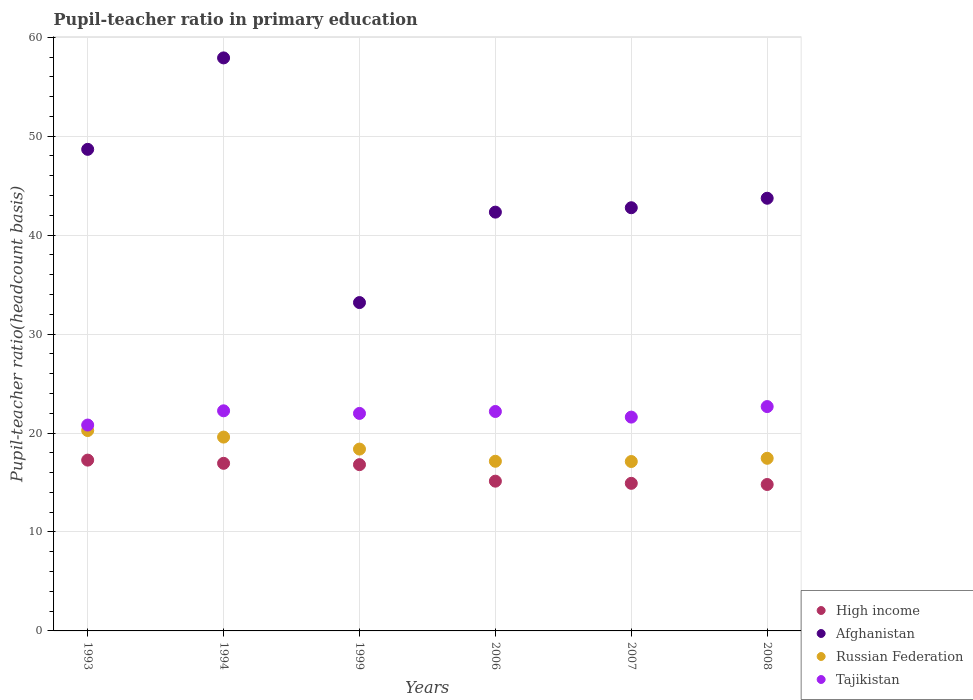How many different coloured dotlines are there?
Offer a terse response. 4. What is the pupil-teacher ratio in primary education in Russian Federation in 1993?
Ensure brevity in your answer.  20.25. Across all years, what is the maximum pupil-teacher ratio in primary education in Afghanistan?
Ensure brevity in your answer.  57.91. Across all years, what is the minimum pupil-teacher ratio in primary education in Tajikistan?
Offer a very short reply. 20.81. In which year was the pupil-teacher ratio in primary education in Tajikistan maximum?
Offer a terse response. 2008. In which year was the pupil-teacher ratio in primary education in High income minimum?
Keep it short and to the point. 2008. What is the total pupil-teacher ratio in primary education in High income in the graph?
Provide a succinct answer. 95.86. What is the difference between the pupil-teacher ratio in primary education in Tajikistan in 1994 and that in 2007?
Provide a short and direct response. 0.64. What is the difference between the pupil-teacher ratio in primary education in High income in 2006 and the pupil-teacher ratio in primary education in Tajikistan in 1993?
Ensure brevity in your answer.  -5.67. What is the average pupil-teacher ratio in primary education in Afghanistan per year?
Keep it short and to the point. 44.77. In the year 1994, what is the difference between the pupil-teacher ratio in primary education in Afghanistan and pupil-teacher ratio in primary education in Russian Federation?
Your answer should be very brief. 38.32. What is the ratio of the pupil-teacher ratio in primary education in High income in 1993 to that in 2007?
Provide a succinct answer. 1.16. Is the difference between the pupil-teacher ratio in primary education in Afghanistan in 2007 and 2008 greater than the difference between the pupil-teacher ratio in primary education in Russian Federation in 2007 and 2008?
Provide a short and direct response. No. What is the difference between the highest and the second highest pupil-teacher ratio in primary education in Russian Federation?
Provide a succinct answer. 0.66. What is the difference between the highest and the lowest pupil-teacher ratio in primary education in Afghanistan?
Make the answer very short. 24.73. In how many years, is the pupil-teacher ratio in primary education in Afghanistan greater than the average pupil-teacher ratio in primary education in Afghanistan taken over all years?
Give a very brief answer. 2. Is it the case that in every year, the sum of the pupil-teacher ratio in primary education in Russian Federation and pupil-teacher ratio in primary education in High income  is greater than the sum of pupil-teacher ratio in primary education in Afghanistan and pupil-teacher ratio in primary education in Tajikistan?
Your response must be concise. No. Is it the case that in every year, the sum of the pupil-teacher ratio in primary education in Afghanistan and pupil-teacher ratio in primary education in High income  is greater than the pupil-teacher ratio in primary education in Russian Federation?
Keep it short and to the point. Yes. Is the pupil-teacher ratio in primary education in Afghanistan strictly less than the pupil-teacher ratio in primary education in Russian Federation over the years?
Ensure brevity in your answer.  No. How many years are there in the graph?
Offer a very short reply. 6. Are the values on the major ticks of Y-axis written in scientific E-notation?
Keep it short and to the point. No. How many legend labels are there?
Offer a terse response. 4. How are the legend labels stacked?
Provide a short and direct response. Vertical. What is the title of the graph?
Your answer should be very brief. Pupil-teacher ratio in primary education. Does "Fragile and conflict affected situations" appear as one of the legend labels in the graph?
Provide a short and direct response. No. What is the label or title of the Y-axis?
Your answer should be compact. Pupil-teacher ratio(headcount basis). What is the Pupil-teacher ratio(headcount basis) in High income in 1993?
Provide a short and direct response. 17.26. What is the Pupil-teacher ratio(headcount basis) of Afghanistan in 1993?
Your answer should be very brief. 48.67. What is the Pupil-teacher ratio(headcount basis) in Russian Federation in 1993?
Provide a short and direct response. 20.25. What is the Pupil-teacher ratio(headcount basis) of Tajikistan in 1993?
Your answer should be compact. 20.81. What is the Pupil-teacher ratio(headcount basis) of High income in 1994?
Ensure brevity in your answer.  16.94. What is the Pupil-teacher ratio(headcount basis) in Afghanistan in 1994?
Provide a short and direct response. 57.91. What is the Pupil-teacher ratio(headcount basis) in Russian Federation in 1994?
Keep it short and to the point. 19.59. What is the Pupil-teacher ratio(headcount basis) of Tajikistan in 1994?
Offer a very short reply. 22.25. What is the Pupil-teacher ratio(headcount basis) in High income in 1999?
Ensure brevity in your answer.  16.8. What is the Pupil-teacher ratio(headcount basis) of Afghanistan in 1999?
Offer a terse response. 33.19. What is the Pupil-teacher ratio(headcount basis) of Russian Federation in 1999?
Offer a terse response. 18.38. What is the Pupil-teacher ratio(headcount basis) of Tajikistan in 1999?
Your response must be concise. 21.98. What is the Pupil-teacher ratio(headcount basis) of High income in 2006?
Give a very brief answer. 15.14. What is the Pupil-teacher ratio(headcount basis) in Afghanistan in 2006?
Ensure brevity in your answer.  42.33. What is the Pupil-teacher ratio(headcount basis) in Russian Federation in 2006?
Your response must be concise. 17.15. What is the Pupil-teacher ratio(headcount basis) of Tajikistan in 2006?
Your answer should be compact. 22.18. What is the Pupil-teacher ratio(headcount basis) of High income in 2007?
Offer a terse response. 14.92. What is the Pupil-teacher ratio(headcount basis) in Afghanistan in 2007?
Ensure brevity in your answer.  42.77. What is the Pupil-teacher ratio(headcount basis) in Russian Federation in 2007?
Provide a short and direct response. 17.12. What is the Pupil-teacher ratio(headcount basis) in Tajikistan in 2007?
Provide a short and direct response. 21.61. What is the Pupil-teacher ratio(headcount basis) of High income in 2008?
Give a very brief answer. 14.8. What is the Pupil-teacher ratio(headcount basis) in Afghanistan in 2008?
Your answer should be compact. 43.73. What is the Pupil-teacher ratio(headcount basis) of Russian Federation in 2008?
Offer a terse response. 17.45. What is the Pupil-teacher ratio(headcount basis) in Tajikistan in 2008?
Provide a short and direct response. 22.67. Across all years, what is the maximum Pupil-teacher ratio(headcount basis) of High income?
Keep it short and to the point. 17.26. Across all years, what is the maximum Pupil-teacher ratio(headcount basis) in Afghanistan?
Your response must be concise. 57.91. Across all years, what is the maximum Pupil-teacher ratio(headcount basis) of Russian Federation?
Make the answer very short. 20.25. Across all years, what is the maximum Pupil-teacher ratio(headcount basis) of Tajikistan?
Give a very brief answer. 22.67. Across all years, what is the minimum Pupil-teacher ratio(headcount basis) in High income?
Your answer should be compact. 14.8. Across all years, what is the minimum Pupil-teacher ratio(headcount basis) in Afghanistan?
Make the answer very short. 33.19. Across all years, what is the minimum Pupil-teacher ratio(headcount basis) in Russian Federation?
Offer a terse response. 17.12. Across all years, what is the minimum Pupil-teacher ratio(headcount basis) of Tajikistan?
Provide a succinct answer. 20.81. What is the total Pupil-teacher ratio(headcount basis) in High income in the graph?
Your response must be concise. 95.86. What is the total Pupil-teacher ratio(headcount basis) of Afghanistan in the graph?
Provide a short and direct response. 268.6. What is the total Pupil-teacher ratio(headcount basis) in Russian Federation in the graph?
Make the answer very short. 109.93. What is the total Pupil-teacher ratio(headcount basis) of Tajikistan in the graph?
Your response must be concise. 131.5. What is the difference between the Pupil-teacher ratio(headcount basis) in High income in 1993 and that in 1994?
Keep it short and to the point. 0.32. What is the difference between the Pupil-teacher ratio(headcount basis) of Afghanistan in 1993 and that in 1994?
Your answer should be compact. -9.24. What is the difference between the Pupil-teacher ratio(headcount basis) in Russian Federation in 1993 and that in 1994?
Keep it short and to the point. 0.66. What is the difference between the Pupil-teacher ratio(headcount basis) of Tajikistan in 1993 and that in 1994?
Offer a terse response. -1.44. What is the difference between the Pupil-teacher ratio(headcount basis) in High income in 1993 and that in 1999?
Keep it short and to the point. 0.46. What is the difference between the Pupil-teacher ratio(headcount basis) of Afghanistan in 1993 and that in 1999?
Keep it short and to the point. 15.49. What is the difference between the Pupil-teacher ratio(headcount basis) in Russian Federation in 1993 and that in 1999?
Keep it short and to the point. 1.87. What is the difference between the Pupil-teacher ratio(headcount basis) of Tajikistan in 1993 and that in 1999?
Make the answer very short. -1.18. What is the difference between the Pupil-teacher ratio(headcount basis) of High income in 1993 and that in 2006?
Your answer should be compact. 2.13. What is the difference between the Pupil-teacher ratio(headcount basis) of Afghanistan in 1993 and that in 2006?
Offer a very short reply. 6.35. What is the difference between the Pupil-teacher ratio(headcount basis) of Russian Federation in 1993 and that in 2006?
Ensure brevity in your answer.  3.1. What is the difference between the Pupil-teacher ratio(headcount basis) of Tajikistan in 1993 and that in 2006?
Give a very brief answer. -1.37. What is the difference between the Pupil-teacher ratio(headcount basis) in High income in 1993 and that in 2007?
Make the answer very short. 2.35. What is the difference between the Pupil-teacher ratio(headcount basis) of Afghanistan in 1993 and that in 2007?
Offer a terse response. 5.9. What is the difference between the Pupil-teacher ratio(headcount basis) of Russian Federation in 1993 and that in 2007?
Make the answer very short. 3.13. What is the difference between the Pupil-teacher ratio(headcount basis) of Tajikistan in 1993 and that in 2007?
Make the answer very short. -0.8. What is the difference between the Pupil-teacher ratio(headcount basis) of High income in 1993 and that in 2008?
Offer a terse response. 2.46. What is the difference between the Pupil-teacher ratio(headcount basis) of Afghanistan in 1993 and that in 2008?
Keep it short and to the point. 4.94. What is the difference between the Pupil-teacher ratio(headcount basis) of Russian Federation in 1993 and that in 2008?
Your answer should be compact. 2.81. What is the difference between the Pupil-teacher ratio(headcount basis) of Tajikistan in 1993 and that in 2008?
Provide a succinct answer. -1.87. What is the difference between the Pupil-teacher ratio(headcount basis) in High income in 1994 and that in 1999?
Give a very brief answer. 0.14. What is the difference between the Pupil-teacher ratio(headcount basis) in Afghanistan in 1994 and that in 1999?
Your response must be concise. 24.73. What is the difference between the Pupil-teacher ratio(headcount basis) of Russian Federation in 1994 and that in 1999?
Your answer should be very brief. 1.21. What is the difference between the Pupil-teacher ratio(headcount basis) of Tajikistan in 1994 and that in 1999?
Provide a short and direct response. 0.26. What is the difference between the Pupil-teacher ratio(headcount basis) in High income in 1994 and that in 2006?
Provide a succinct answer. 1.8. What is the difference between the Pupil-teacher ratio(headcount basis) in Afghanistan in 1994 and that in 2006?
Offer a terse response. 15.59. What is the difference between the Pupil-teacher ratio(headcount basis) of Russian Federation in 1994 and that in 2006?
Offer a very short reply. 2.44. What is the difference between the Pupil-teacher ratio(headcount basis) of Tajikistan in 1994 and that in 2006?
Keep it short and to the point. 0.07. What is the difference between the Pupil-teacher ratio(headcount basis) in High income in 1994 and that in 2007?
Your answer should be compact. 2.02. What is the difference between the Pupil-teacher ratio(headcount basis) in Afghanistan in 1994 and that in 2007?
Offer a very short reply. 15.14. What is the difference between the Pupil-teacher ratio(headcount basis) in Russian Federation in 1994 and that in 2007?
Offer a terse response. 2.47. What is the difference between the Pupil-teacher ratio(headcount basis) in Tajikistan in 1994 and that in 2007?
Provide a short and direct response. 0.64. What is the difference between the Pupil-teacher ratio(headcount basis) in High income in 1994 and that in 2008?
Your answer should be very brief. 2.14. What is the difference between the Pupil-teacher ratio(headcount basis) in Afghanistan in 1994 and that in 2008?
Keep it short and to the point. 14.18. What is the difference between the Pupil-teacher ratio(headcount basis) in Russian Federation in 1994 and that in 2008?
Offer a very short reply. 2.14. What is the difference between the Pupil-teacher ratio(headcount basis) of Tajikistan in 1994 and that in 2008?
Your answer should be very brief. -0.43. What is the difference between the Pupil-teacher ratio(headcount basis) in High income in 1999 and that in 2006?
Your response must be concise. 1.67. What is the difference between the Pupil-teacher ratio(headcount basis) in Afghanistan in 1999 and that in 2006?
Your answer should be compact. -9.14. What is the difference between the Pupil-teacher ratio(headcount basis) in Russian Federation in 1999 and that in 2006?
Make the answer very short. 1.23. What is the difference between the Pupil-teacher ratio(headcount basis) of Tajikistan in 1999 and that in 2006?
Provide a short and direct response. -0.2. What is the difference between the Pupil-teacher ratio(headcount basis) in High income in 1999 and that in 2007?
Make the answer very short. 1.89. What is the difference between the Pupil-teacher ratio(headcount basis) in Afghanistan in 1999 and that in 2007?
Provide a succinct answer. -9.58. What is the difference between the Pupil-teacher ratio(headcount basis) of Russian Federation in 1999 and that in 2007?
Ensure brevity in your answer.  1.26. What is the difference between the Pupil-teacher ratio(headcount basis) in Tajikistan in 1999 and that in 2007?
Make the answer very short. 0.37. What is the difference between the Pupil-teacher ratio(headcount basis) of High income in 1999 and that in 2008?
Offer a terse response. 2.01. What is the difference between the Pupil-teacher ratio(headcount basis) in Afghanistan in 1999 and that in 2008?
Provide a succinct answer. -10.54. What is the difference between the Pupil-teacher ratio(headcount basis) of Russian Federation in 1999 and that in 2008?
Provide a succinct answer. 0.93. What is the difference between the Pupil-teacher ratio(headcount basis) of Tajikistan in 1999 and that in 2008?
Provide a succinct answer. -0.69. What is the difference between the Pupil-teacher ratio(headcount basis) of High income in 2006 and that in 2007?
Keep it short and to the point. 0.22. What is the difference between the Pupil-teacher ratio(headcount basis) in Afghanistan in 2006 and that in 2007?
Offer a terse response. -0.44. What is the difference between the Pupil-teacher ratio(headcount basis) of Russian Federation in 2006 and that in 2007?
Offer a terse response. 0.03. What is the difference between the Pupil-teacher ratio(headcount basis) in Tajikistan in 2006 and that in 2007?
Offer a very short reply. 0.57. What is the difference between the Pupil-teacher ratio(headcount basis) in High income in 2006 and that in 2008?
Give a very brief answer. 0.34. What is the difference between the Pupil-teacher ratio(headcount basis) of Afghanistan in 2006 and that in 2008?
Provide a succinct answer. -1.4. What is the difference between the Pupil-teacher ratio(headcount basis) in Tajikistan in 2006 and that in 2008?
Ensure brevity in your answer.  -0.5. What is the difference between the Pupil-teacher ratio(headcount basis) of High income in 2007 and that in 2008?
Keep it short and to the point. 0.12. What is the difference between the Pupil-teacher ratio(headcount basis) of Afghanistan in 2007 and that in 2008?
Provide a succinct answer. -0.96. What is the difference between the Pupil-teacher ratio(headcount basis) of Russian Federation in 2007 and that in 2008?
Keep it short and to the point. -0.33. What is the difference between the Pupil-teacher ratio(headcount basis) in Tajikistan in 2007 and that in 2008?
Your answer should be very brief. -1.06. What is the difference between the Pupil-teacher ratio(headcount basis) in High income in 1993 and the Pupil-teacher ratio(headcount basis) in Afghanistan in 1994?
Your answer should be very brief. -40.65. What is the difference between the Pupil-teacher ratio(headcount basis) of High income in 1993 and the Pupil-teacher ratio(headcount basis) of Russian Federation in 1994?
Your response must be concise. -2.33. What is the difference between the Pupil-teacher ratio(headcount basis) in High income in 1993 and the Pupil-teacher ratio(headcount basis) in Tajikistan in 1994?
Make the answer very short. -4.98. What is the difference between the Pupil-teacher ratio(headcount basis) in Afghanistan in 1993 and the Pupil-teacher ratio(headcount basis) in Russian Federation in 1994?
Offer a terse response. 29.08. What is the difference between the Pupil-teacher ratio(headcount basis) of Afghanistan in 1993 and the Pupil-teacher ratio(headcount basis) of Tajikistan in 1994?
Your answer should be very brief. 26.43. What is the difference between the Pupil-teacher ratio(headcount basis) of Russian Federation in 1993 and the Pupil-teacher ratio(headcount basis) of Tajikistan in 1994?
Make the answer very short. -1.99. What is the difference between the Pupil-teacher ratio(headcount basis) in High income in 1993 and the Pupil-teacher ratio(headcount basis) in Afghanistan in 1999?
Ensure brevity in your answer.  -15.92. What is the difference between the Pupil-teacher ratio(headcount basis) in High income in 1993 and the Pupil-teacher ratio(headcount basis) in Russian Federation in 1999?
Your response must be concise. -1.11. What is the difference between the Pupil-teacher ratio(headcount basis) of High income in 1993 and the Pupil-teacher ratio(headcount basis) of Tajikistan in 1999?
Keep it short and to the point. -4.72. What is the difference between the Pupil-teacher ratio(headcount basis) in Afghanistan in 1993 and the Pupil-teacher ratio(headcount basis) in Russian Federation in 1999?
Offer a terse response. 30.29. What is the difference between the Pupil-teacher ratio(headcount basis) in Afghanistan in 1993 and the Pupil-teacher ratio(headcount basis) in Tajikistan in 1999?
Give a very brief answer. 26.69. What is the difference between the Pupil-teacher ratio(headcount basis) in Russian Federation in 1993 and the Pupil-teacher ratio(headcount basis) in Tajikistan in 1999?
Give a very brief answer. -1.73. What is the difference between the Pupil-teacher ratio(headcount basis) in High income in 1993 and the Pupil-teacher ratio(headcount basis) in Afghanistan in 2006?
Your answer should be compact. -25.06. What is the difference between the Pupil-teacher ratio(headcount basis) of High income in 1993 and the Pupil-teacher ratio(headcount basis) of Russian Federation in 2006?
Offer a terse response. 0.12. What is the difference between the Pupil-teacher ratio(headcount basis) of High income in 1993 and the Pupil-teacher ratio(headcount basis) of Tajikistan in 2006?
Make the answer very short. -4.92. What is the difference between the Pupil-teacher ratio(headcount basis) in Afghanistan in 1993 and the Pupil-teacher ratio(headcount basis) in Russian Federation in 2006?
Offer a terse response. 31.52. What is the difference between the Pupil-teacher ratio(headcount basis) of Afghanistan in 1993 and the Pupil-teacher ratio(headcount basis) of Tajikistan in 2006?
Your answer should be very brief. 26.49. What is the difference between the Pupil-teacher ratio(headcount basis) of Russian Federation in 1993 and the Pupil-teacher ratio(headcount basis) of Tajikistan in 2006?
Your response must be concise. -1.93. What is the difference between the Pupil-teacher ratio(headcount basis) of High income in 1993 and the Pupil-teacher ratio(headcount basis) of Afghanistan in 2007?
Offer a very short reply. -25.51. What is the difference between the Pupil-teacher ratio(headcount basis) of High income in 1993 and the Pupil-teacher ratio(headcount basis) of Russian Federation in 2007?
Ensure brevity in your answer.  0.14. What is the difference between the Pupil-teacher ratio(headcount basis) of High income in 1993 and the Pupil-teacher ratio(headcount basis) of Tajikistan in 2007?
Make the answer very short. -4.35. What is the difference between the Pupil-teacher ratio(headcount basis) of Afghanistan in 1993 and the Pupil-teacher ratio(headcount basis) of Russian Federation in 2007?
Give a very brief answer. 31.55. What is the difference between the Pupil-teacher ratio(headcount basis) in Afghanistan in 1993 and the Pupil-teacher ratio(headcount basis) in Tajikistan in 2007?
Give a very brief answer. 27.06. What is the difference between the Pupil-teacher ratio(headcount basis) in Russian Federation in 1993 and the Pupil-teacher ratio(headcount basis) in Tajikistan in 2007?
Provide a succinct answer. -1.36. What is the difference between the Pupil-teacher ratio(headcount basis) of High income in 1993 and the Pupil-teacher ratio(headcount basis) of Afghanistan in 2008?
Provide a short and direct response. -26.47. What is the difference between the Pupil-teacher ratio(headcount basis) of High income in 1993 and the Pupil-teacher ratio(headcount basis) of Russian Federation in 2008?
Ensure brevity in your answer.  -0.18. What is the difference between the Pupil-teacher ratio(headcount basis) of High income in 1993 and the Pupil-teacher ratio(headcount basis) of Tajikistan in 2008?
Your answer should be compact. -5.41. What is the difference between the Pupil-teacher ratio(headcount basis) in Afghanistan in 1993 and the Pupil-teacher ratio(headcount basis) in Russian Federation in 2008?
Provide a short and direct response. 31.22. What is the difference between the Pupil-teacher ratio(headcount basis) in Afghanistan in 1993 and the Pupil-teacher ratio(headcount basis) in Tajikistan in 2008?
Your answer should be very brief. 26. What is the difference between the Pupil-teacher ratio(headcount basis) in Russian Federation in 1993 and the Pupil-teacher ratio(headcount basis) in Tajikistan in 2008?
Provide a succinct answer. -2.42. What is the difference between the Pupil-teacher ratio(headcount basis) of High income in 1994 and the Pupil-teacher ratio(headcount basis) of Afghanistan in 1999?
Your response must be concise. -16.25. What is the difference between the Pupil-teacher ratio(headcount basis) of High income in 1994 and the Pupil-teacher ratio(headcount basis) of Russian Federation in 1999?
Provide a succinct answer. -1.44. What is the difference between the Pupil-teacher ratio(headcount basis) of High income in 1994 and the Pupil-teacher ratio(headcount basis) of Tajikistan in 1999?
Your answer should be compact. -5.04. What is the difference between the Pupil-teacher ratio(headcount basis) of Afghanistan in 1994 and the Pupil-teacher ratio(headcount basis) of Russian Federation in 1999?
Make the answer very short. 39.54. What is the difference between the Pupil-teacher ratio(headcount basis) of Afghanistan in 1994 and the Pupil-teacher ratio(headcount basis) of Tajikistan in 1999?
Provide a short and direct response. 35.93. What is the difference between the Pupil-teacher ratio(headcount basis) of Russian Federation in 1994 and the Pupil-teacher ratio(headcount basis) of Tajikistan in 1999?
Provide a succinct answer. -2.39. What is the difference between the Pupil-teacher ratio(headcount basis) of High income in 1994 and the Pupil-teacher ratio(headcount basis) of Afghanistan in 2006?
Offer a very short reply. -25.39. What is the difference between the Pupil-teacher ratio(headcount basis) in High income in 1994 and the Pupil-teacher ratio(headcount basis) in Russian Federation in 2006?
Offer a terse response. -0.21. What is the difference between the Pupil-teacher ratio(headcount basis) of High income in 1994 and the Pupil-teacher ratio(headcount basis) of Tajikistan in 2006?
Make the answer very short. -5.24. What is the difference between the Pupil-teacher ratio(headcount basis) of Afghanistan in 1994 and the Pupil-teacher ratio(headcount basis) of Russian Federation in 2006?
Your response must be concise. 40.77. What is the difference between the Pupil-teacher ratio(headcount basis) in Afghanistan in 1994 and the Pupil-teacher ratio(headcount basis) in Tajikistan in 2006?
Offer a terse response. 35.73. What is the difference between the Pupil-teacher ratio(headcount basis) in Russian Federation in 1994 and the Pupil-teacher ratio(headcount basis) in Tajikistan in 2006?
Provide a succinct answer. -2.59. What is the difference between the Pupil-teacher ratio(headcount basis) of High income in 1994 and the Pupil-teacher ratio(headcount basis) of Afghanistan in 2007?
Ensure brevity in your answer.  -25.83. What is the difference between the Pupil-teacher ratio(headcount basis) in High income in 1994 and the Pupil-teacher ratio(headcount basis) in Russian Federation in 2007?
Your answer should be compact. -0.18. What is the difference between the Pupil-teacher ratio(headcount basis) in High income in 1994 and the Pupil-teacher ratio(headcount basis) in Tajikistan in 2007?
Your answer should be very brief. -4.67. What is the difference between the Pupil-teacher ratio(headcount basis) in Afghanistan in 1994 and the Pupil-teacher ratio(headcount basis) in Russian Federation in 2007?
Ensure brevity in your answer.  40.79. What is the difference between the Pupil-teacher ratio(headcount basis) in Afghanistan in 1994 and the Pupil-teacher ratio(headcount basis) in Tajikistan in 2007?
Your answer should be very brief. 36.3. What is the difference between the Pupil-teacher ratio(headcount basis) in Russian Federation in 1994 and the Pupil-teacher ratio(headcount basis) in Tajikistan in 2007?
Your answer should be very brief. -2.02. What is the difference between the Pupil-teacher ratio(headcount basis) of High income in 1994 and the Pupil-teacher ratio(headcount basis) of Afghanistan in 2008?
Make the answer very short. -26.79. What is the difference between the Pupil-teacher ratio(headcount basis) of High income in 1994 and the Pupil-teacher ratio(headcount basis) of Russian Federation in 2008?
Keep it short and to the point. -0.51. What is the difference between the Pupil-teacher ratio(headcount basis) in High income in 1994 and the Pupil-teacher ratio(headcount basis) in Tajikistan in 2008?
Your answer should be very brief. -5.74. What is the difference between the Pupil-teacher ratio(headcount basis) in Afghanistan in 1994 and the Pupil-teacher ratio(headcount basis) in Russian Federation in 2008?
Ensure brevity in your answer.  40.47. What is the difference between the Pupil-teacher ratio(headcount basis) in Afghanistan in 1994 and the Pupil-teacher ratio(headcount basis) in Tajikistan in 2008?
Ensure brevity in your answer.  35.24. What is the difference between the Pupil-teacher ratio(headcount basis) in Russian Federation in 1994 and the Pupil-teacher ratio(headcount basis) in Tajikistan in 2008?
Offer a terse response. -3.08. What is the difference between the Pupil-teacher ratio(headcount basis) in High income in 1999 and the Pupil-teacher ratio(headcount basis) in Afghanistan in 2006?
Your answer should be compact. -25.52. What is the difference between the Pupil-teacher ratio(headcount basis) in High income in 1999 and the Pupil-teacher ratio(headcount basis) in Russian Federation in 2006?
Your response must be concise. -0.34. What is the difference between the Pupil-teacher ratio(headcount basis) in High income in 1999 and the Pupil-teacher ratio(headcount basis) in Tajikistan in 2006?
Give a very brief answer. -5.37. What is the difference between the Pupil-teacher ratio(headcount basis) of Afghanistan in 1999 and the Pupil-teacher ratio(headcount basis) of Russian Federation in 2006?
Offer a very short reply. 16.04. What is the difference between the Pupil-teacher ratio(headcount basis) of Afghanistan in 1999 and the Pupil-teacher ratio(headcount basis) of Tajikistan in 2006?
Your answer should be very brief. 11.01. What is the difference between the Pupil-teacher ratio(headcount basis) in Russian Federation in 1999 and the Pupil-teacher ratio(headcount basis) in Tajikistan in 2006?
Offer a terse response. -3.8. What is the difference between the Pupil-teacher ratio(headcount basis) of High income in 1999 and the Pupil-teacher ratio(headcount basis) of Afghanistan in 2007?
Your answer should be compact. -25.97. What is the difference between the Pupil-teacher ratio(headcount basis) in High income in 1999 and the Pupil-teacher ratio(headcount basis) in Russian Federation in 2007?
Provide a succinct answer. -0.32. What is the difference between the Pupil-teacher ratio(headcount basis) of High income in 1999 and the Pupil-teacher ratio(headcount basis) of Tajikistan in 2007?
Offer a terse response. -4.81. What is the difference between the Pupil-teacher ratio(headcount basis) of Afghanistan in 1999 and the Pupil-teacher ratio(headcount basis) of Russian Federation in 2007?
Keep it short and to the point. 16.06. What is the difference between the Pupil-teacher ratio(headcount basis) of Afghanistan in 1999 and the Pupil-teacher ratio(headcount basis) of Tajikistan in 2007?
Give a very brief answer. 11.58. What is the difference between the Pupil-teacher ratio(headcount basis) of Russian Federation in 1999 and the Pupil-teacher ratio(headcount basis) of Tajikistan in 2007?
Give a very brief answer. -3.23. What is the difference between the Pupil-teacher ratio(headcount basis) of High income in 1999 and the Pupil-teacher ratio(headcount basis) of Afghanistan in 2008?
Provide a short and direct response. -26.93. What is the difference between the Pupil-teacher ratio(headcount basis) in High income in 1999 and the Pupil-teacher ratio(headcount basis) in Russian Federation in 2008?
Make the answer very short. -0.64. What is the difference between the Pupil-teacher ratio(headcount basis) of High income in 1999 and the Pupil-teacher ratio(headcount basis) of Tajikistan in 2008?
Keep it short and to the point. -5.87. What is the difference between the Pupil-teacher ratio(headcount basis) in Afghanistan in 1999 and the Pupil-teacher ratio(headcount basis) in Russian Federation in 2008?
Give a very brief answer. 15.74. What is the difference between the Pupil-teacher ratio(headcount basis) of Afghanistan in 1999 and the Pupil-teacher ratio(headcount basis) of Tajikistan in 2008?
Give a very brief answer. 10.51. What is the difference between the Pupil-teacher ratio(headcount basis) in Russian Federation in 1999 and the Pupil-teacher ratio(headcount basis) in Tajikistan in 2008?
Make the answer very short. -4.3. What is the difference between the Pupil-teacher ratio(headcount basis) in High income in 2006 and the Pupil-teacher ratio(headcount basis) in Afghanistan in 2007?
Your response must be concise. -27.64. What is the difference between the Pupil-teacher ratio(headcount basis) of High income in 2006 and the Pupil-teacher ratio(headcount basis) of Russian Federation in 2007?
Ensure brevity in your answer.  -1.99. What is the difference between the Pupil-teacher ratio(headcount basis) of High income in 2006 and the Pupil-teacher ratio(headcount basis) of Tajikistan in 2007?
Provide a succinct answer. -6.47. What is the difference between the Pupil-teacher ratio(headcount basis) in Afghanistan in 2006 and the Pupil-teacher ratio(headcount basis) in Russian Federation in 2007?
Provide a succinct answer. 25.2. What is the difference between the Pupil-teacher ratio(headcount basis) of Afghanistan in 2006 and the Pupil-teacher ratio(headcount basis) of Tajikistan in 2007?
Provide a short and direct response. 20.72. What is the difference between the Pupil-teacher ratio(headcount basis) of Russian Federation in 2006 and the Pupil-teacher ratio(headcount basis) of Tajikistan in 2007?
Ensure brevity in your answer.  -4.46. What is the difference between the Pupil-teacher ratio(headcount basis) in High income in 2006 and the Pupil-teacher ratio(headcount basis) in Afghanistan in 2008?
Your answer should be compact. -28.59. What is the difference between the Pupil-teacher ratio(headcount basis) of High income in 2006 and the Pupil-teacher ratio(headcount basis) of Russian Federation in 2008?
Provide a short and direct response. -2.31. What is the difference between the Pupil-teacher ratio(headcount basis) in High income in 2006 and the Pupil-teacher ratio(headcount basis) in Tajikistan in 2008?
Ensure brevity in your answer.  -7.54. What is the difference between the Pupil-teacher ratio(headcount basis) in Afghanistan in 2006 and the Pupil-teacher ratio(headcount basis) in Russian Federation in 2008?
Make the answer very short. 24.88. What is the difference between the Pupil-teacher ratio(headcount basis) of Afghanistan in 2006 and the Pupil-teacher ratio(headcount basis) of Tajikistan in 2008?
Provide a succinct answer. 19.65. What is the difference between the Pupil-teacher ratio(headcount basis) of Russian Federation in 2006 and the Pupil-teacher ratio(headcount basis) of Tajikistan in 2008?
Provide a short and direct response. -5.53. What is the difference between the Pupil-teacher ratio(headcount basis) of High income in 2007 and the Pupil-teacher ratio(headcount basis) of Afghanistan in 2008?
Make the answer very short. -28.81. What is the difference between the Pupil-teacher ratio(headcount basis) in High income in 2007 and the Pupil-teacher ratio(headcount basis) in Russian Federation in 2008?
Your answer should be very brief. -2.53. What is the difference between the Pupil-teacher ratio(headcount basis) of High income in 2007 and the Pupil-teacher ratio(headcount basis) of Tajikistan in 2008?
Provide a short and direct response. -7.76. What is the difference between the Pupil-teacher ratio(headcount basis) of Afghanistan in 2007 and the Pupil-teacher ratio(headcount basis) of Russian Federation in 2008?
Keep it short and to the point. 25.32. What is the difference between the Pupil-teacher ratio(headcount basis) in Afghanistan in 2007 and the Pupil-teacher ratio(headcount basis) in Tajikistan in 2008?
Keep it short and to the point. 20.1. What is the difference between the Pupil-teacher ratio(headcount basis) of Russian Federation in 2007 and the Pupil-teacher ratio(headcount basis) of Tajikistan in 2008?
Offer a very short reply. -5.55. What is the average Pupil-teacher ratio(headcount basis) in High income per year?
Offer a very short reply. 15.98. What is the average Pupil-teacher ratio(headcount basis) of Afghanistan per year?
Your answer should be very brief. 44.77. What is the average Pupil-teacher ratio(headcount basis) in Russian Federation per year?
Your answer should be compact. 18.32. What is the average Pupil-teacher ratio(headcount basis) in Tajikistan per year?
Ensure brevity in your answer.  21.92. In the year 1993, what is the difference between the Pupil-teacher ratio(headcount basis) of High income and Pupil-teacher ratio(headcount basis) of Afghanistan?
Your answer should be very brief. -31.41. In the year 1993, what is the difference between the Pupil-teacher ratio(headcount basis) in High income and Pupil-teacher ratio(headcount basis) in Russian Federation?
Your answer should be very brief. -2.99. In the year 1993, what is the difference between the Pupil-teacher ratio(headcount basis) of High income and Pupil-teacher ratio(headcount basis) of Tajikistan?
Ensure brevity in your answer.  -3.54. In the year 1993, what is the difference between the Pupil-teacher ratio(headcount basis) of Afghanistan and Pupil-teacher ratio(headcount basis) of Russian Federation?
Provide a short and direct response. 28.42. In the year 1993, what is the difference between the Pupil-teacher ratio(headcount basis) in Afghanistan and Pupil-teacher ratio(headcount basis) in Tajikistan?
Give a very brief answer. 27.86. In the year 1993, what is the difference between the Pupil-teacher ratio(headcount basis) in Russian Federation and Pupil-teacher ratio(headcount basis) in Tajikistan?
Provide a short and direct response. -0.56. In the year 1994, what is the difference between the Pupil-teacher ratio(headcount basis) of High income and Pupil-teacher ratio(headcount basis) of Afghanistan?
Your answer should be compact. -40.97. In the year 1994, what is the difference between the Pupil-teacher ratio(headcount basis) of High income and Pupil-teacher ratio(headcount basis) of Russian Federation?
Offer a very short reply. -2.65. In the year 1994, what is the difference between the Pupil-teacher ratio(headcount basis) in High income and Pupil-teacher ratio(headcount basis) in Tajikistan?
Offer a terse response. -5.31. In the year 1994, what is the difference between the Pupil-teacher ratio(headcount basis) of Afghanistan and Pupil-teacher ratio(headcount basis) of Russian Federation?
Your answer should be compact. 38.32. In the year 1994, what is the difference between the Pupil-teacher ratio(headcount basis) in Afghanistan and Pupil-teacher ratio(headcount basis) in Tajikistan?
Keep it short and to the point. 35.67. In the year 1994, what is the difference between the Pupil-teacher ratio(headcount basis) in Russian Federation and Pupil-teacher ratio(headcount basis) in Tajikistan?
Provide a short and direct response. -2.66. In the year 1999, what is the difference between the Pupil-teacher ratio(headcount basis) in High income and Pupil-teacher ratio(headcount basis) in Afghanistan?
Give a very brief answer. -16.38. In the year 1999, what is the difference between the Pupil-teacher ratio(headcount basis) in High income and Pupil-teacher ratio(headcount basis) in Russian Federation?
Your response must be concise. -1.57. In the year 1999, what is the difference between the Pupil-teacher ratio(headcount basis) of High income and Pupil-teacher ratio(headcount basis) of Tajikistan?
Offer a terse response. -5.18. In the year 1999, what is the difference between the Pupil-teacher ratio(headcount basis) in Afghanistan and Pupil-teacher ratio(headcount basis) in Russian Federation?
Give a very brief answer. 14.81. In the year 1999, what is the difference between the Pupil-teacher ratio(headcount basis) of Afghanistan and Pupil-teacher ratio(headcount basis) of Tajikistan?
Make the answer very short. 11.2. In the year 1999, what is the difference between the Pupil-teacher ratio(headcount basis) in Russian Federation and Pupil-teacher ratio(headcount basis) in Tajikistan?
Your answer should be very brief. -3.61. In the year 2006, what is the difference between the Pupil-teacher ratio(headcount basis) of High income and Pupil-teacher ratio(headcount basis) of Afghanistan?
Your answer should be very brief. -27.19. In the year 2006, what is the difference between the Pupil-teacher ratio(headcount basis) in High income and Pupil-teacher ratio(headcount basis) in Russian Federation?
Offer a terse response. -2.01. In the year 2006, what is the difference between the Pupil-teacher ratio(headcount basis) of High income and Pupil-teacher ratio(headcount basis) of Tajikistan?
Keep it short and to the point. -7.04. In the year 2006, what is the difference between the Pupil-teacher ratio(headcount basis) in Afghanistan and Pupil-teacher ratio(headcount basis) in Russian Federation?
Your answer should be very brief. 25.18. In the year 2006, what is the difference between the Pupil-teacher ratio(headcount basis) of Afghanistan and Pupil-teacher ratio(headcount basis) of Tajikistan?
Make the answer very short. 20.15. In the year 2006, what is the difference between the Pupil-teacher ratio(headcount basis) of Russian Federation and Pupil-teacher ratio(headcount basis) of Tajikistan?
Offer a very short reply. -5.03. In the year 2007, what is the difference between the Pupil-teacher ratio(headcount basis) in High income and Pupil-teacher ratio(headcount basis) in Afghanistan?
Keep it short and to the point. -27.85. In the year 2007, what is the difference between the Pupil-teacher ratio(headcount basis) in High income and Pupil-teacher ratio(headcount basis) in Russian Federation?
Provide a short and direct response. -2.2. In the year 2007, what is the difference between the Pupil-teacher ratio(headcount basis) of High income and Pupil-teacher ratio(headcount basis) of Tajikistan?
Provide a succinct answer. -6.69. In the year 2007, what is the difference between the Pupil-teacher ratio(headcount basis) in Afghanistan and Pupil-teacher ratio(headcount basis) in Russian Federation?
Provide a short and direct response. 25.65. In the year 2007, what is the difference between the Pupil-teacher ratio(headcount basis) in Afghanistan and Pupil-teacher ratio(headcount basis) in Tajikistan?
Make the answer very short. 21.16. In the year 2007, what is the difference between the Pupil-teacher ratio(headcount basis) of Russian Federation and Pupil-teacher ratio(headcount basis) of Tajikistan?
Keep it short and to the point. -4.49. In the year 2008, what is the difference between the Pupil-teacher ratio(headcount basis) in High income and Pupil-teacher ratio(headcount basis) in Afghanistan?
Ensure brevity in your answer.  -28.93. In the year 2008, what is the difference between the Pupil-teacher ratio(headcount basis) in High income and Pupil-teacher ratio(headcount basis) in Russian Federation?
Offer a terse response. -2.65. In the year 2008, what is the difference between the Pupil-teacher ratio(headcount basis) of High income and Pupil-teacher ratio(headcount basis) of Tajikistan?
Ensure brevity in your answer.  -7.88. In the year 2008, what is the difference between the Pupil-teacher ratio(headcount basis) in Afghanistan and Pupil-teacher ratio(headcount basis) in Russian Federation?
Keep it short and to the point. 26.28. In the year 2008, what is the difference between the Pupil-teacher ratio(headcount basis) in Afghanistan and Pupil-teacher ratio(headcount basis) in Tajikistan?
Offer a very short reply. 21.06. In the year 2008, what is the difference between the Pupil-teacher ratio(headcount basis) in Russian Federation and Pupil-teacher ratio(headcount basis) in Tajikistan?
Offer a terse response. -5.23. What is the ratio of the Pupil-teacher ratio(headcount basis) in High income in 1993 to that in 1994?
Offer a terse response. 1.02. What is the ratio of the Pupil-teacher ratio(headcount basis) of Afghanistan in 1993 to that in 1994?
Offer a very short reply. 0.84. What is the ratio of the Pupil-teacher ratio(headcount basis) in Russian Federation in 1993 to that in 1994?
Give a very brief answer. 1.03. What is the ratio of the Pupil-teacher ratio(headcount basis) of Tajikistan in 1993 to that in 1994?
Keep it short and to the point. 0.94. What is the ratio of the Pupil-teacher ratio(headcount basis) in High income in 1993 to that in 1999?
Provide a succinct answer. 1.03. What is the ratio of the Pupil-teacher ratio(headcount basis) of Afghanistan in 1993 to that in 1999?
Offer a terse response. 1.47. What is the ratio of the Pupil-teacher ratio(headcount basis) of Russian Federation in 1993 to that in 1999?
Offer a terse response. 1.1. What is the ratio of the Pupil-teacher ratio(headcount basis) in Tajikistan in 1993 to that in 1999?
Your response must be concise. 0.95. What is the ratio of the Pupil-teacher ratio(headcount basis) of High income in 1993 to that in 2006?
Your response must be concise. 1.14. What is the ratio of the Pupil-teacher ratio(headcount basis) in Afghanistan in 1993 to that in 2006?
Your answer should be compact. 1.15. What is the ratio of the Pupil-teacher ratio(headcount basis) in Russian Federation in 1993 to that in 2006?
Your answer should be compact. 1.18. What is the ratio of the Pupil-teacher ratio(headcount basis) of Tajikistan in 1993 to that in 2006?
Your answer should be very brief. 0.94. What is the ratio of the Pupil-teacher ratio(headcount basis) of High income in 1993 to that in 2007?
Ensure brevity in your answer.  1.16. What is the ratio of the Pupil-teacher ratio(headcount basis) in Afghanistan in 1993 to that in 2007?
Give a very brief answer. 1.14. What is the ratio of the Pupil-teacher ratio(headcount basis) in Russian Federation in 1993 to that in 2007?
Make the answer very short. 1.18. What is the ratio of the Pupil-teacher ratio(headcount basis) of Tajikistan in 1993 to that in 2007?
Your answer should be very brief. 0.96. What is the ratio of the Pupil-teacher ratio(headcount basis) of High income in 1993 to that in 2008?
Offer a very short reply. 1.17. What is the ratio of the Pupil-teacher ratio(headcount basis) of Afghanistan in 1993 to that in 2008?
Provide a succinct answer. 1.11. What is the ratio of the Pupil-teacher ratio(headcount basis) of Russian Federation in 1993 to that in 2008?
Your answer should be very brief. 1.16. What is the ratio of the Pupil-teacher ratio(headcount basis) of Tajikistan in 1993 to that in 2008?
Provide a short and direct response. 0.92. What is the ratio of the Pupil-teacher ratio(headcount basis) in Afghanistan in 1994 to that in 1999?
Ensure brevity in your answer.  1.75. What is the ratio of the Pupil-teacher ratio(headcount basis) of Russian Federation in 1994 to that in 1999?
Your response must be concise. 1.07. What is the ratio of the Pupil-teacher ratio(headcount basis) in Tajikistan in 1994 to that in 1999?
Provide a short and direct response. 1.01. What is the ratio of the Pupil-teacher ratio(headcount basis) of High income in 1994 to that in 2006?
Provide a short and direct response. 1.12. What is the ratio of the Pupil-teacher ratio(headcount basis) in Afghanistan in 1994 to that in 2006?
Offer a very short reply. 1.37. What is the ratio of the Pupil-teacher ratio(headcount basis) in Russian Federation in 1994 to that in 2006?
Offer a very short reply. 1.14. What is the ratio of the Pupil-teacher ratio(headcount basis) in Tajikistan in 1994 to that in 2006?
Make the answer very short. 1. What is the ratio of the Pupil-teacher ratio(headcount basis) in High income in 1994 to that in 2007?
Provide a short and direct response. 1.14. What is the ratio of the Pupil-teacher ratio(headcount basis) of Afghanistan in 1994 to that in 2007?
Ensure brevity in your answer.  1.35. What is the ratio of the Pupil-teacher ratio(headcount basis) in Russian Federation in 1994 to that in 2007?
Ensure brevity in your answer.  1.14. What is the ratio of the Pupil-teacher ratio(headcount basis) in Tajikistan in 1994 to that in 2007?
Your answer should be compact. 1.03. What is the ratio of the Pupil-teacher ratio(headcount basis) in High income in 1994 to that in 2008?
Offer a terse response. 1.14. What is the ratio of the Pupil-teacher ratio(headcount basis) in Afghanistan in 1994 to that in 2008?
Provide a short and direct response. 1.32. What is the ratio of the Pupil-teacher ratio(headcount basis) in Russian Federation in 1994 to that in 2008?
Your answer should be compact. 1.12. What is the ratio of the Pupil-teacher ratio(headcount basis) of Tajikistan in 1994 to that in 2008?
Your answer should be very brief. 0.98. What is the ratio of the Pupil-teacher ratio(headcount basis) in High income in 1999 to that in 2006?
Ensure brevity in your answer.  1.11. What is the ratio of the Pupil-teacher ratio(headcount basis) in Afghanistan in 1999 to that in 2006?
Offer a terse response. 0.78. What is the ratio of the Pupil-teacher ratio(headcount basis) in Russian Federation in 1999 to that in 2006?
Make the answer very short. 1.07. What is the ratio of the Pupil-teacher ratio(headcount basis) of Tajikistan in 1999 to that in 2006?
Your response must be concise. 0.99. What is the ratio of the Pupil-teacher ratio(headcount basis) of High income in 1999 to that in 2007?
Provide a succinct answer. 1.13. What is the ratio of the Pupil-teacher ratio(headcount basis) in Afghanistan in 1999 to that in 2007?
Provide a short and direct response. 0.78. What is the ratio of the Pupil-teacher ratio(headcount basis) of Russian Federation in 1999 to that in 2007?
Your response must be concise. 1.07. What is the ratio of the Pupil-teacher ratio(headcount basis) of Tajikistan in 1999 to that in 2007?
Offer a terse response. 1.02. What is the ratio of the Pupil-teacher ratio(headcount basis) of High income in 1999 to that in 2008?
Provide a succinct answer. 1.14. What is the ratio of the Pupil-teacher ratio(headcount basis) in Afghanistan in 1999 to that in 2008?
Provide a succinct answer. 0.76. What is the ratio of the Pupil-teacher ratio(headcount basis) of Russian Federation in 1999 to that in 2008?
Give a very brief answer. 1.05. What is the ratio of the Pupil-teacher ratio(headcount basis) in Tajikistan in 1999 to that in 2008?
Make the answer very short. 0.97. What is the ratio of the Pupil-teacher ratio(headcount basis) in High income in 2006 to that in 2007?
Your response must be concise. 1.01. What is the ratio of the Pupil-teacher ratio(headcount basis) in Afghanistan in 2006 to that in 2007?
Provide a short and direct response. 0.99. What is the ratio of the Pupil-teacher ratio(headcount basis) in Tajikistan in 2006 to that in 2007?
Give a very brief answer. 1.03. What is the ratio of the Pupil-teacher ratio(headcount basis) in High income in 2006 to that in 2008?
Your answer should be very brief. 1.02. What is the ratio of the Pupil-teacher ratio(headcount basis) in Afghanistan in 2006 to that in 2008?
Offer a terse response. 0.97. What is the ratio of the Pupil-teacher ratio(headcount basis) of Russian Federation in 2006 to that in 2008?
Your answer should be compact. 0.98. What is the ratio of the Pupil-teacher ratio(headcount basis) in Tajikistan in 2006 to that in 2008?
Give a very brief answer. 0.98. What is the ratio of the Pupil-teacher ratio(headcount basis) of High income in 2007 to that in 2008?
Ensure brevity in your answer.  1.01. What is the ratio of the Pupil-teacher ratio(headcount basis) of Afghanistan in 2007 to that in 2008?
Your answer should be compact. 0.98. What is the ratio of the Pupil-teacher ratio(headcount basis) of Russian Federation in 2007 to that in 2008?
Ensure brevity in your answer.  0.98. What is the ratio of the Pupil-teacher ratio(headcount basis) of Tajikistan in 2007 to that in 2008?
Offer a terse response. 0.95. What is the difference between the highest and the second highest Pupil-teacher ratio(headcount basis) of High income?
Keep it short and to the point. 0.32. What is the difference between the highest and the second highest Pupil-teacher ratio(headcount basis) of Afghanistan?
Ensure brevity in your answer.  9.24. What is the difference between the highest and the second highest Pupil-teacher ratio(headcount basis) in Russian Federation?
Keep it short and to the point. 0.66. What is the difference between the highest and the second highest Pupil-teacher ratio(headcount basis) of Tajikistan?
Give a very brief answer. 0.43. What is the difference between the highest and the lowest Pupil-teacher ratio(headcount basis) in High income?
Make the answer very short. 2.46. What is the difference between the highest and the lowest Pupil-teacher ratio(headcount basis) of Afghanistan?
Your answer should be very brief. 24.73. What is the difference between the highest and the lowest Pupil-teacher ratio(headcount basis) in Russian Federation?
Offer a terse response. 3.13. What is the difference between the highest and the lowest Pupil-teacher ratio(headcount basis) in Tajikistan?
Provide a short and direct response. 1.87. 